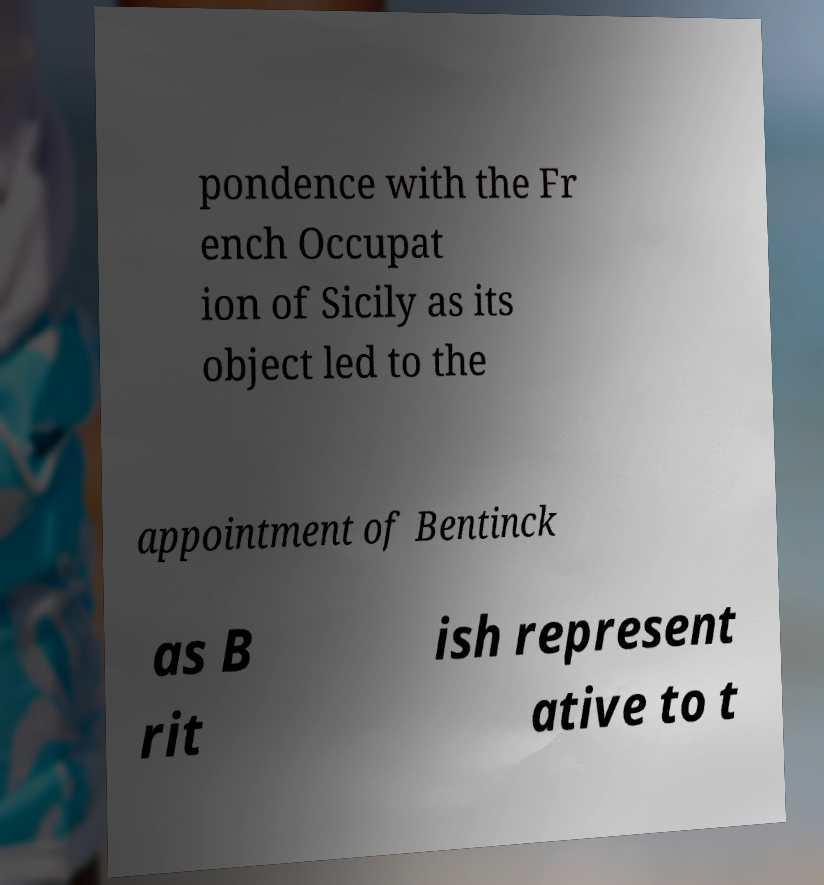For documentation purposes, I need the text within this image transcribed. Could you provide that? pondence with the Fr ench Occupat ion of Sicily as its object led to the appointment of Bentinck as B rit ish represent ative to t 